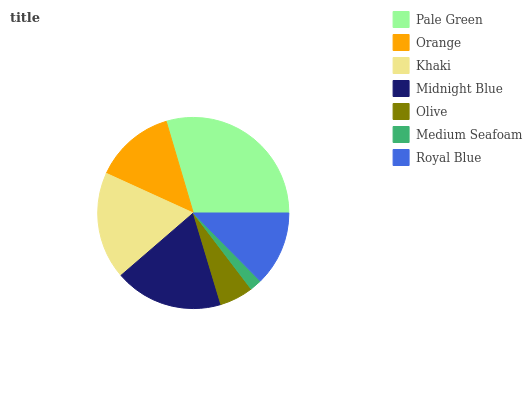Is Medium Seafoam the minimum?
Answer yes or no. Yes. Is Pale Green the maximum?
Answer yes or no. Yes. Is Orange the minimum?
Answer yes or no. No. Is Orange the maximum?
Answer yes or no. No. Is Pale Green greater than Orange?
Answer yes or no. Yes. Is Orange less than Pale Green?
Answer yes or no. Yes. Is Orange greater than Pale Green?
Answer yes or no. No. Is Pale Green less than Orange?
Answer yes or no. No. Is Orange the high median?
Answer yes or no. Yes. Is Orange the low median?
Answer yes or no. Yes. Is Royal Blue the high median?
Answer yes or no. No. Is Khaki the low median?
Answer yes or no. No. 